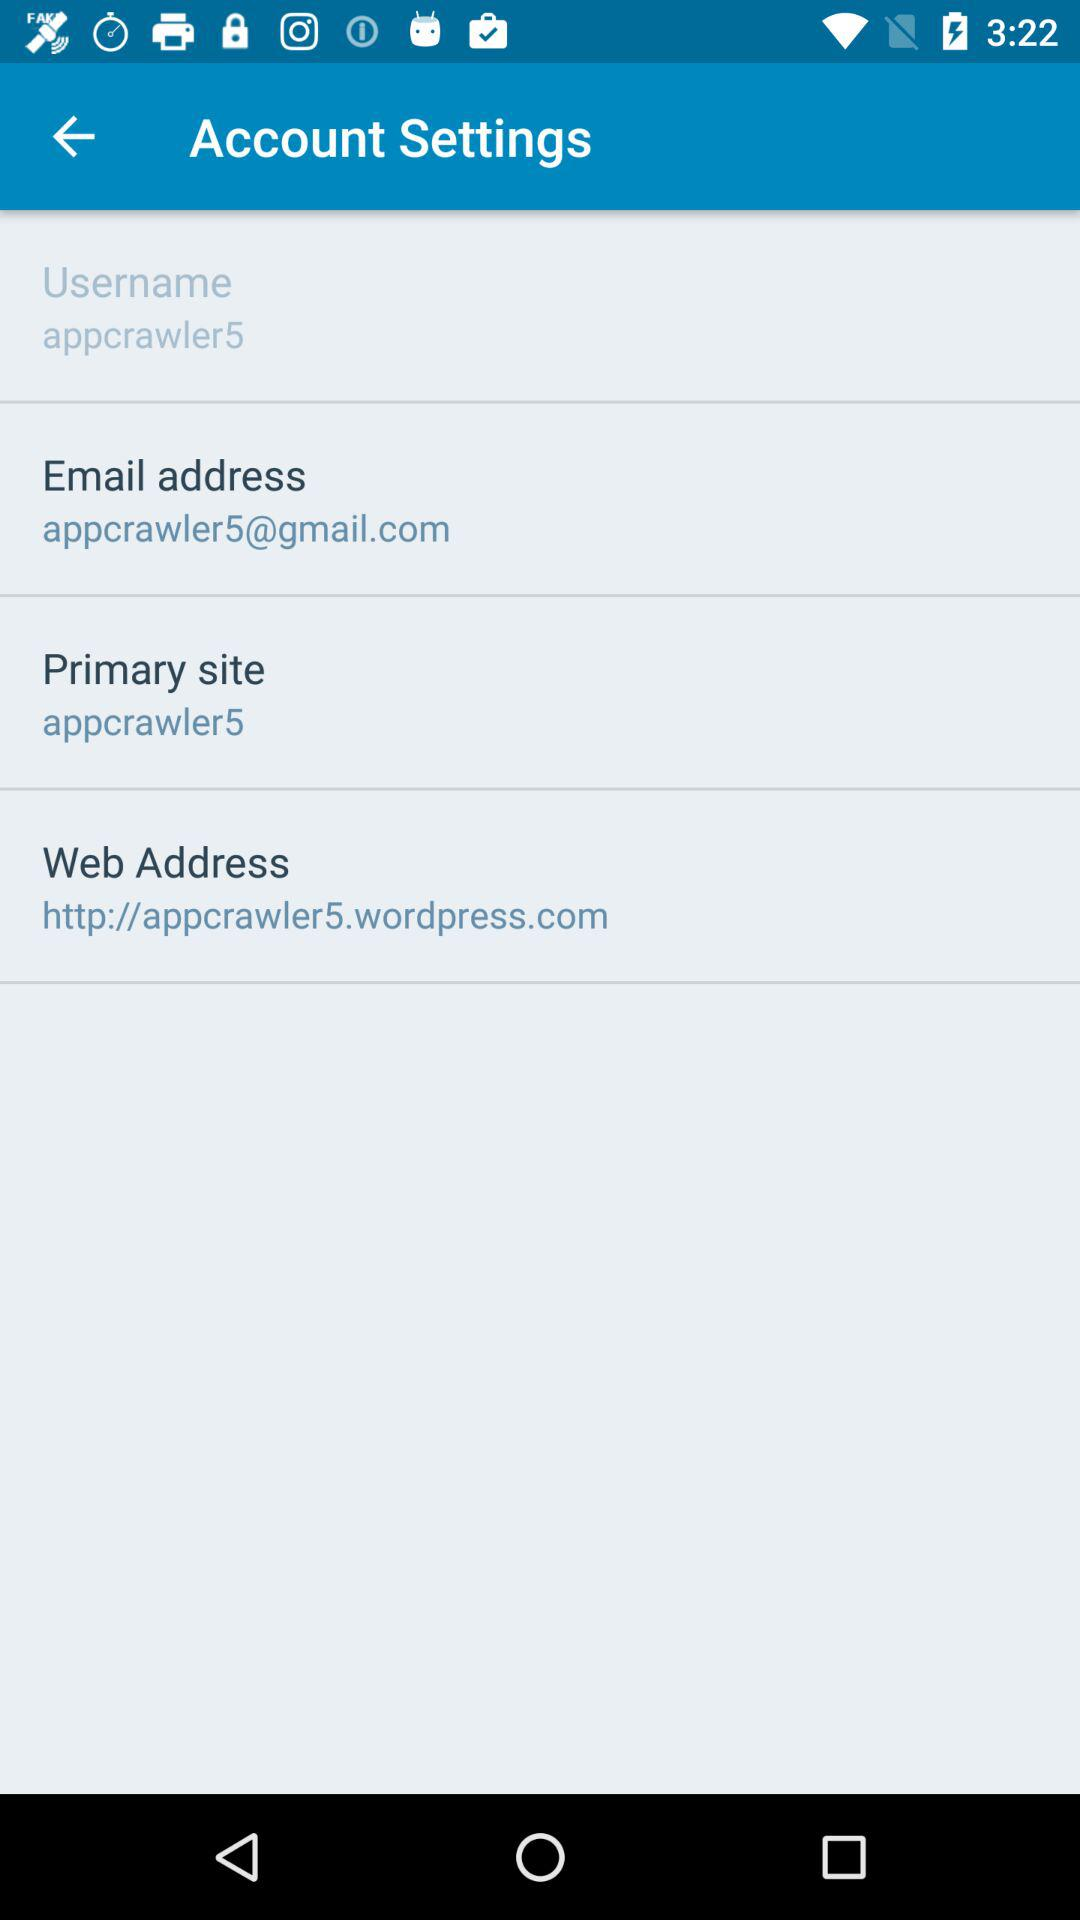What's the web address? The web address is http://appcrawler5.wordpress.com. 